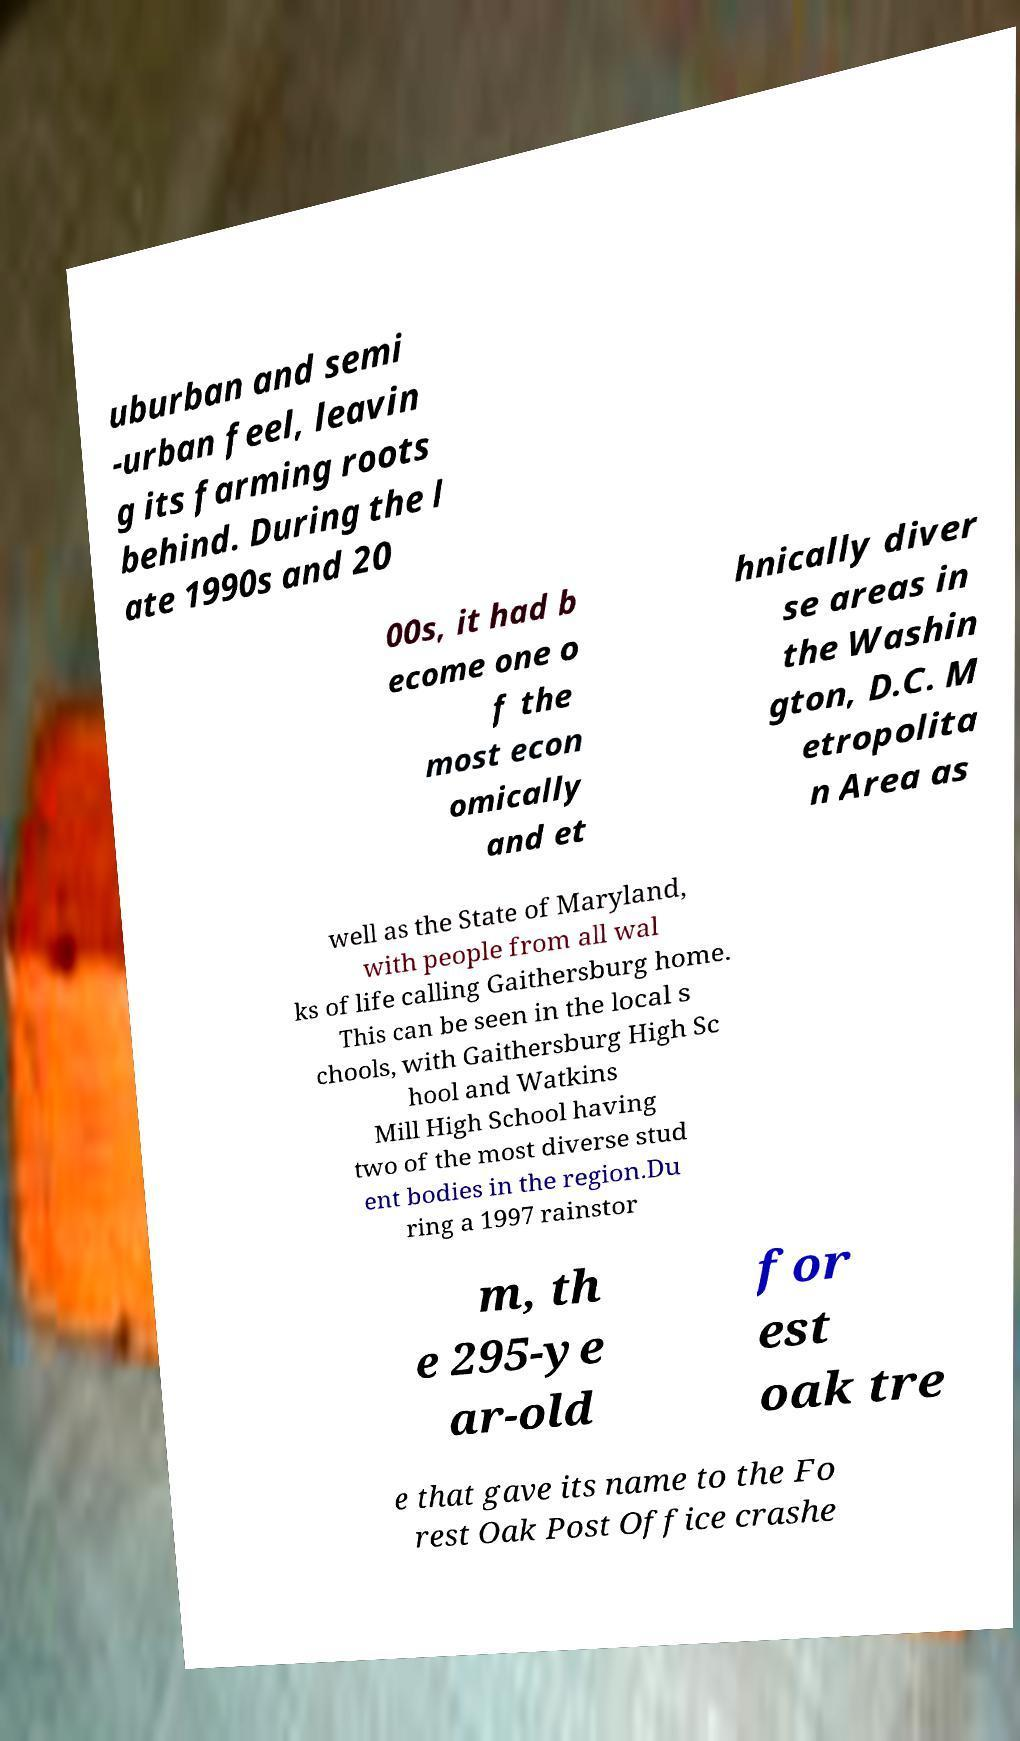Can you read and provide the text displayed in the image?This photo seems to have some interesting text. Can you extract and type it out for me? uburban and semi -urban feel, leavin g its farming roots behind. During the l ate 1990s and 20 00s, it had b ecome one o f the most econ omically and et hnically diver se areas in the Washin gton, D.C. M etropolita n Area as well as the State of Maryland, with people from all wal ks of life calling Gaithersburg home. This can be seen in the local s chools, with Gaithersburg High Sc hool and Watkins Mill High School having two of the most diverse stud ent bodies in the region.Du ring a 1997 rainstor m, th e 295-ye ar-old for est oak tre e that gave its name to the Fo rest Oak Post Office crashe 